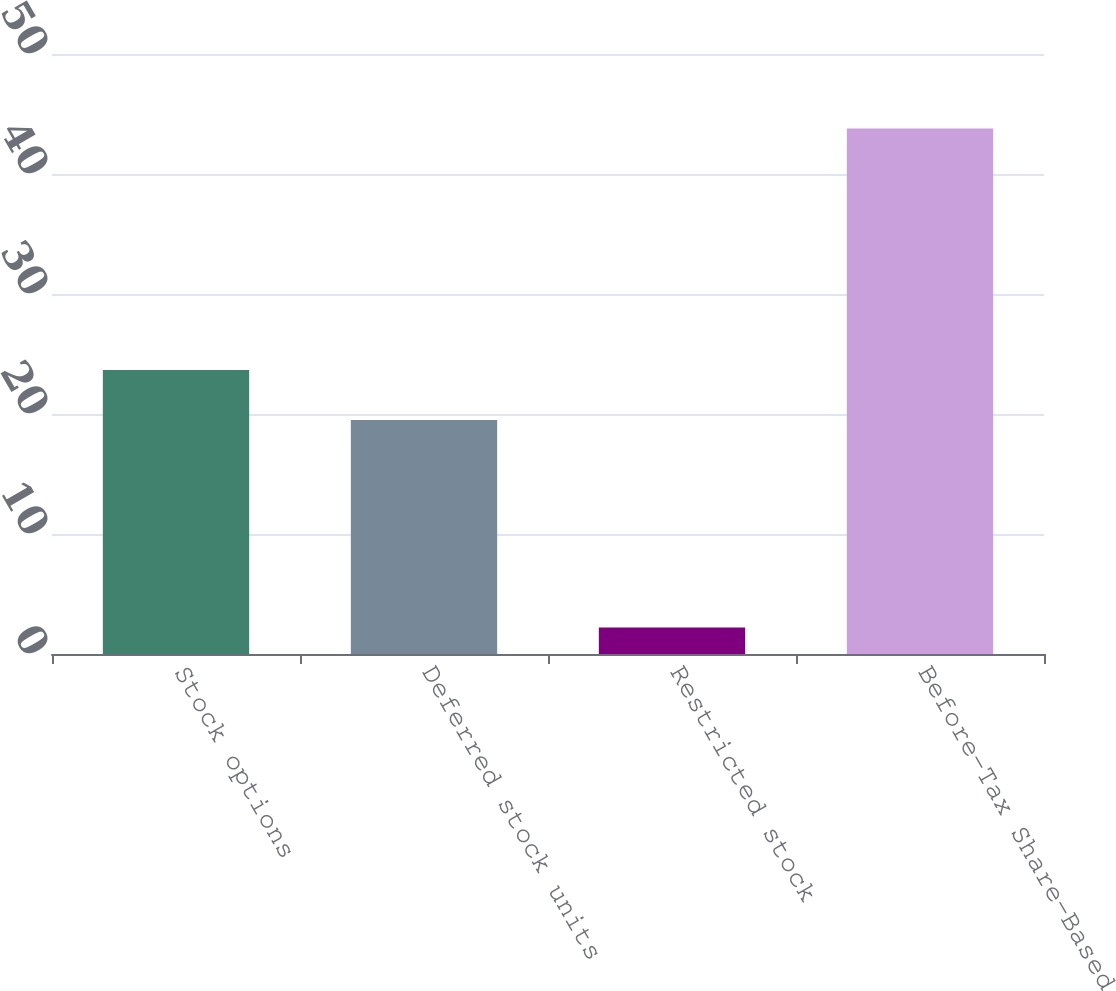<chart> <loc_0><loc_0><loc_500><loc_500><bar_chart><fcel>Stock options<fcel>Deferred stock units<fcel>Restricted stock<fcel>Before-Tax Share-Based<nl><fcel>23.66<fcel>19.5<fcel>2.2<fcel>43.8<nl></chart> 